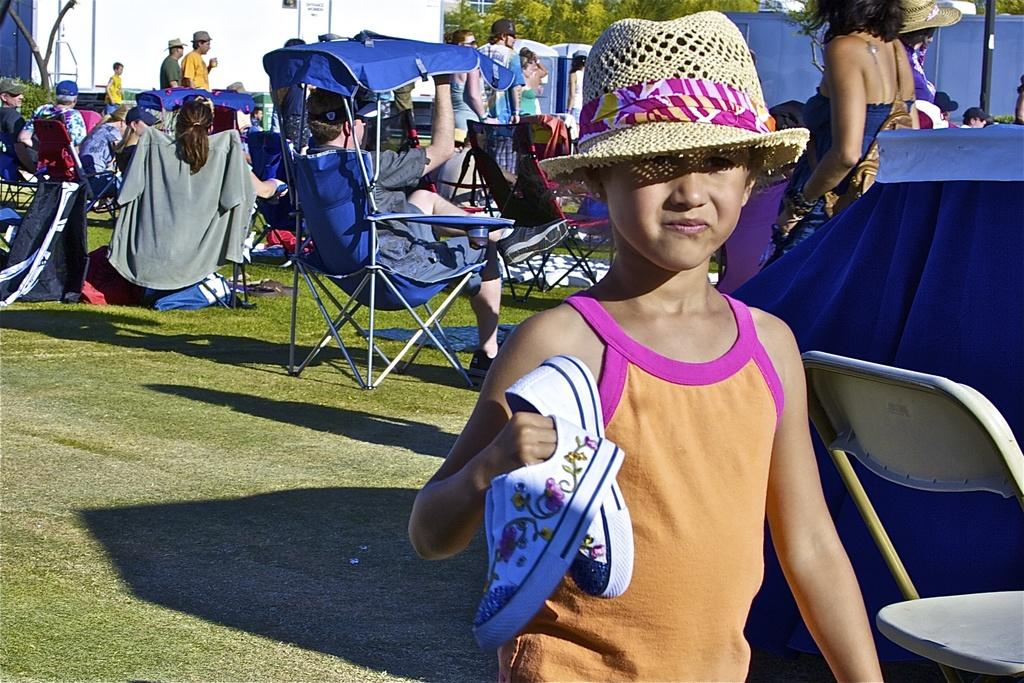What is the main subject of the image? There is a child in the image. What is the child wearing on her head? The child is wearing a hat. What is the child holding in her right hand? The child is holding shoes in her right hand. Can you describe the background of the image? There are many people in the background of the image. What type of prose can be heard being read aloud in the image? There is no indication in the image that any prose is being read aloud. How does the child rub her hands together in the image? The child is not rubbing her hands together in the image; she is holding shoes in her right hand. 